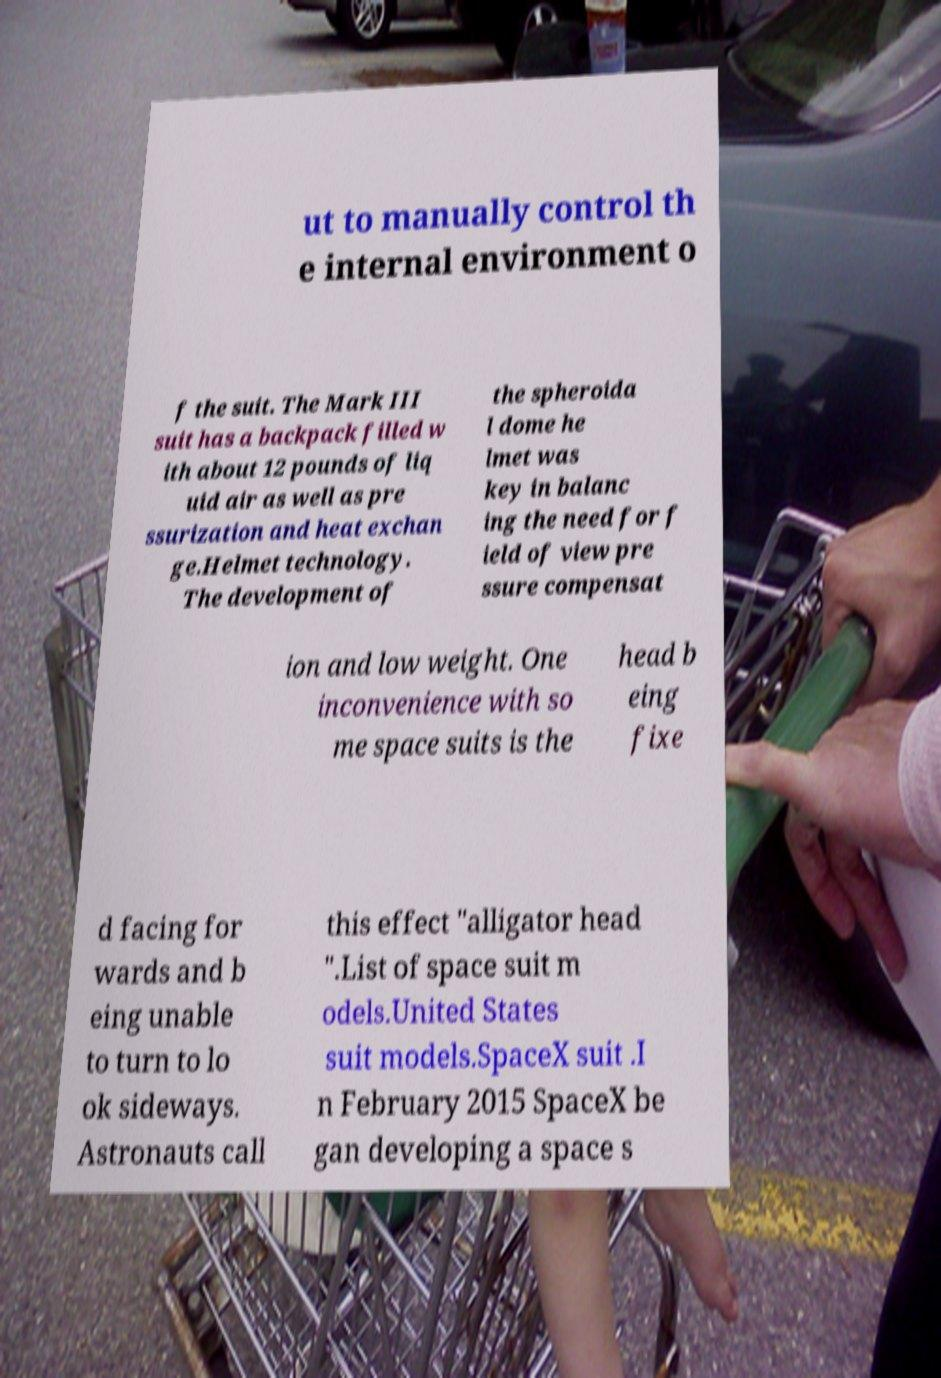There's text embedded in this image that I need extracted. Can you transcribe it verbatim? ut to manually control th e internal environment o f the suit. The Mark III suit has a backpack filled w ith about 12 pounds of liq uid air as well as pre ssurization and heat exchan ge.Helmet technology. The development of the spheroida l dome he lmet was key in balanc ing the need for f ield of view pre ssure compensat ion and low weight. One inconvenience with so me space suits is the head b eing fixe d facing for wards and b eing unable to turn to lo ok sideways. Astronauts call this effect "alligator head ".List of space suit m odels.United States suit models.SpaceX suit .I n February 2015 SpaceX be gan developing a space s 